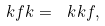Convert formula to latex. <formula><loc_0><loc_0><loc_500><loc_500>\ k f k = \ k k f ,</formula> 